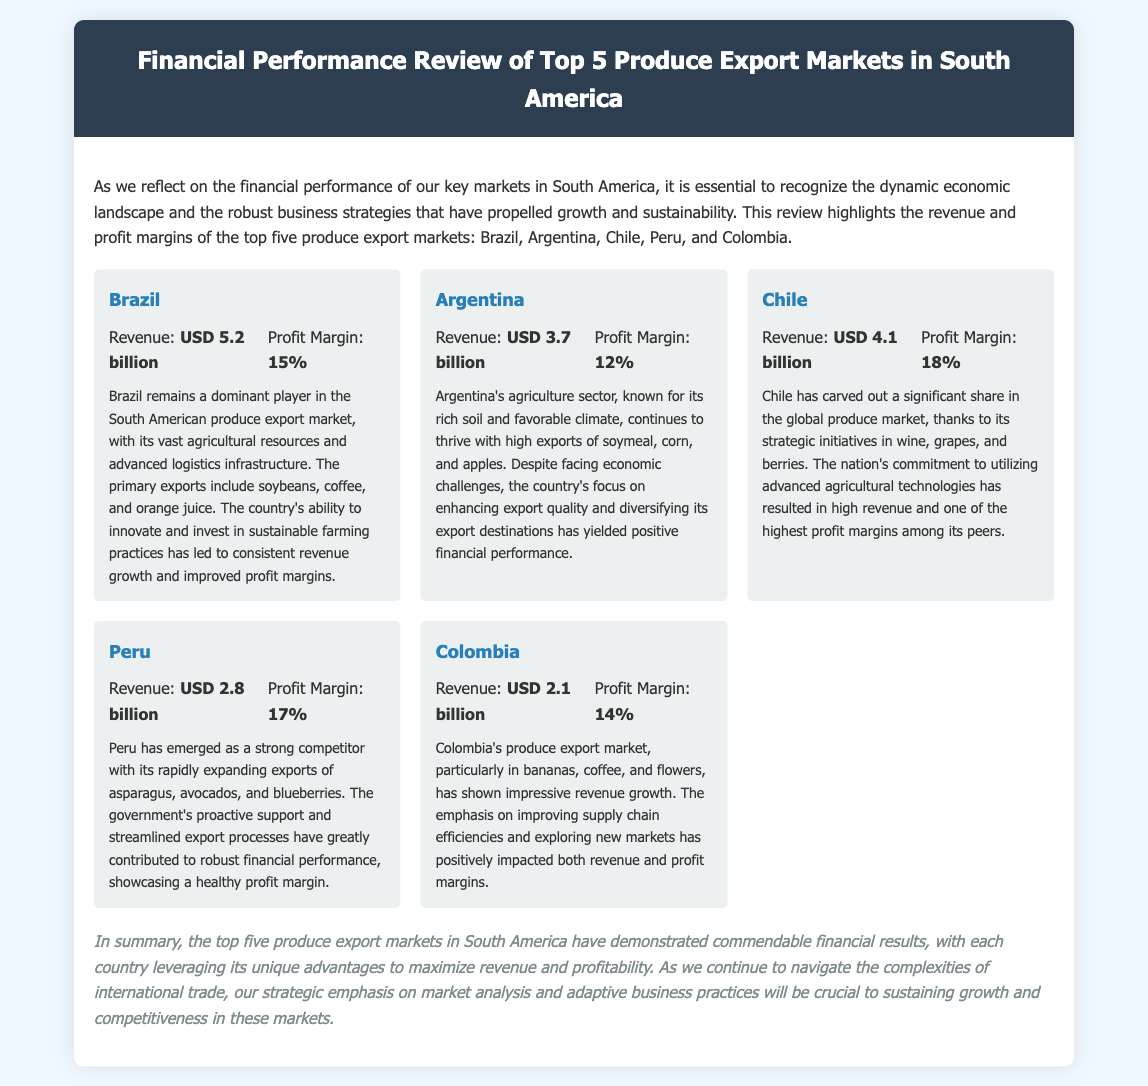What is the revenue of Brazil? Brazil's revenue is clearly stated in the document as USD 5.2 billion.
Answer: USD 5.2 billion What is the profit margin of Chile? The document specifies that Chile has a profit margin of 18%.
Answer: 18% Which country has the highest profit margin? The analysis indicates that Chile, with an 18% profit margin, has the highest among the five countries.
Answer: Chile What is the primary export of Peru? The document mentions that Peru's primary exports include asparagus, avocados, and blueberries.
Answer: Asparagus, avocados, blueberries Which country has the lowest revenue? According to the financial performance review, Colombia has the lowest revenue at USD 2.1 billion.
Answer: USD 2.1 billion Which country's agriculture sector is known for its rich soil? The document highlights Argentina's agriculture sector as known for its rich soil and favorable climate.
Answer: Argentina How many countries are reviewed in this document? The document lists and reviews five produce export markets in South America.
Answer: Five What is the purpose of the financial performance review? The document states that the purpose is to reflect on the financial performance in the dynamic economic landscape.
Answer: To reflect on financial performance 